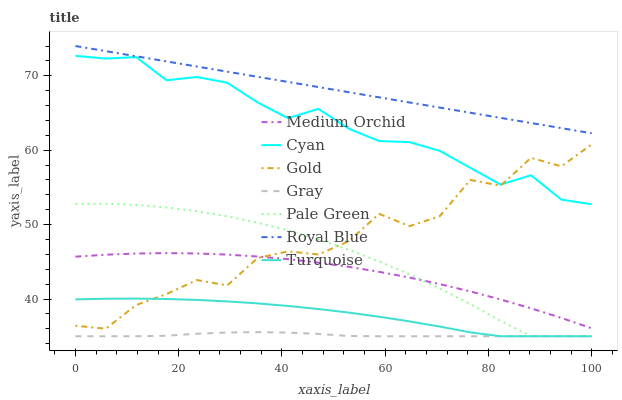Does Gray have the minimum area under the curve?
Answer yes or no. Yes. Does Royal Blue have the maximum area under the curve?
Answer yes or no. Yes. Does Turquoise have the minimum area under the curve?
Answer yes or no. No. Does Turquoise have the maximum area under the curve?
Answer yes or no. No. Is Royal Blue the smoothest?
Answer yes or no. Yes. Is Gold the roughest?
Answer yes or no. Yes. Is Turquoise the smoothest?
Answer yes or no. No. Is Turquoise the roughest?
Answer yes or no. No. Does Gold have the lowest value?
Answer yes or no. No. Does Turquoise have the highest value?
Answer yes or no. No. Is Cyan less than Royal Blue?
Answer yes or no. Yes. Is Gold greater than Gray?
Answer yes or no. Yes. Does Cyan intersect Royal Blue?
Answer yes or no. No. 